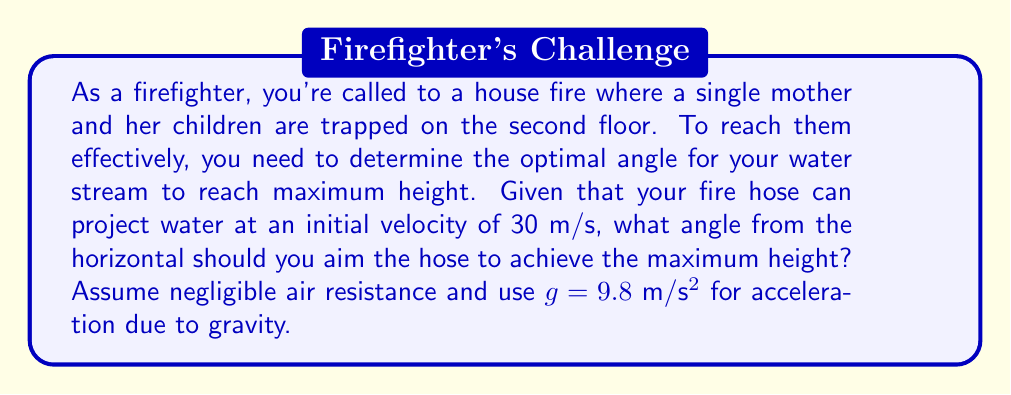Can you answer this question? To solve this problem, we need to use the principles of projectile motion. The optimal angle for maximum height is always 90° (straight up), but this wouldn't be practical for firefighting. For a projectile to reach both maximum height and distance, we need to find the angle that maximizes the vertical component of the velocity while still maintaining a horizontal component.

The equations for the vertical and horizontal components of velocity are:

$v_y = v \sin\theta$
$v_x = v \cos\theta$

Where $v$ is the initial velocity and $\theta$ is the angle from the horizontal.

The maximum height reached by a projectile is given by:

$h_{max} = \frac{v_y^2}{2g}$

Substituting $v_y = v \sin\theta$, we get:

$h_{max} = \frac{(v \sin\theta)^2}{2g} = \frac{v^2 \sin^2\theta}{2g}$

To find the maximum value of this function, we need to differentiate it with respect to $\theta$ and set it to zero:

$\frac{d}{d\theta}(\frac{v^2 \sin^2\theta}{2g}) = \frac{v^2}{g} \sin\theta \cos\theta = 0$

This equation is satisfied when $\sin\theta = 0$ or $\cos\theta = 0$. Since we need a non-zero horizontal component, we choose $\cos\theta = 0$, which occurs when $\theta = 90°$.

However, for practical firefighting purposes, we need to compromise between height and distance. The angle that maximizes both height and distance is 45°. This can be proven mathematically, but it's also intuitive: it's the midpoint between horizontal (0°) and vertical (90°).

Therefore, the optimal angle for a firefighter's water stream to reach maximum practical height while still covering distance is 45°.
Answer: The optimal angle for the firefighter's water stream to reach maximum practical height is 45°. 